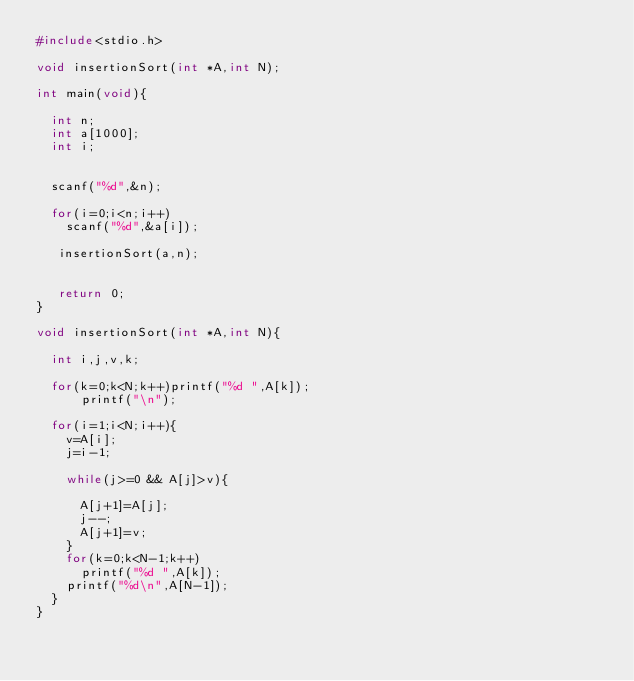<code> <loc_0><loc_0><loc_500><loc_500><_C_>#include<stdio.h>

void insertionSort(int *A,int N);

int main(void){

  int n;
  int a[1000];
  int i;


  scanf("%d",&n);

  for(i=0;i<n;i++)
    scanf("%d",&a[i]);

   insertionSort(a,n);


   return 0;
}

void insertionSort(int *A,int N){

  int i,j,v,k;

  for(k=0;k<N;k++)printf("%d ",A[k]);
      printf("\n");

  for(i=1;i<N;i++){
    v=A[i];
    j=i-1;

    while(j>=0 && A[j]>v){

      A[j+1]=A[j];
      j--;
      A[j+1]=v;
    }
    for(k=0;k<N-1;k++)
      printf("%d ",A[k]);
    printf("%d\n",A[N-1]);
  }
}

</code> 